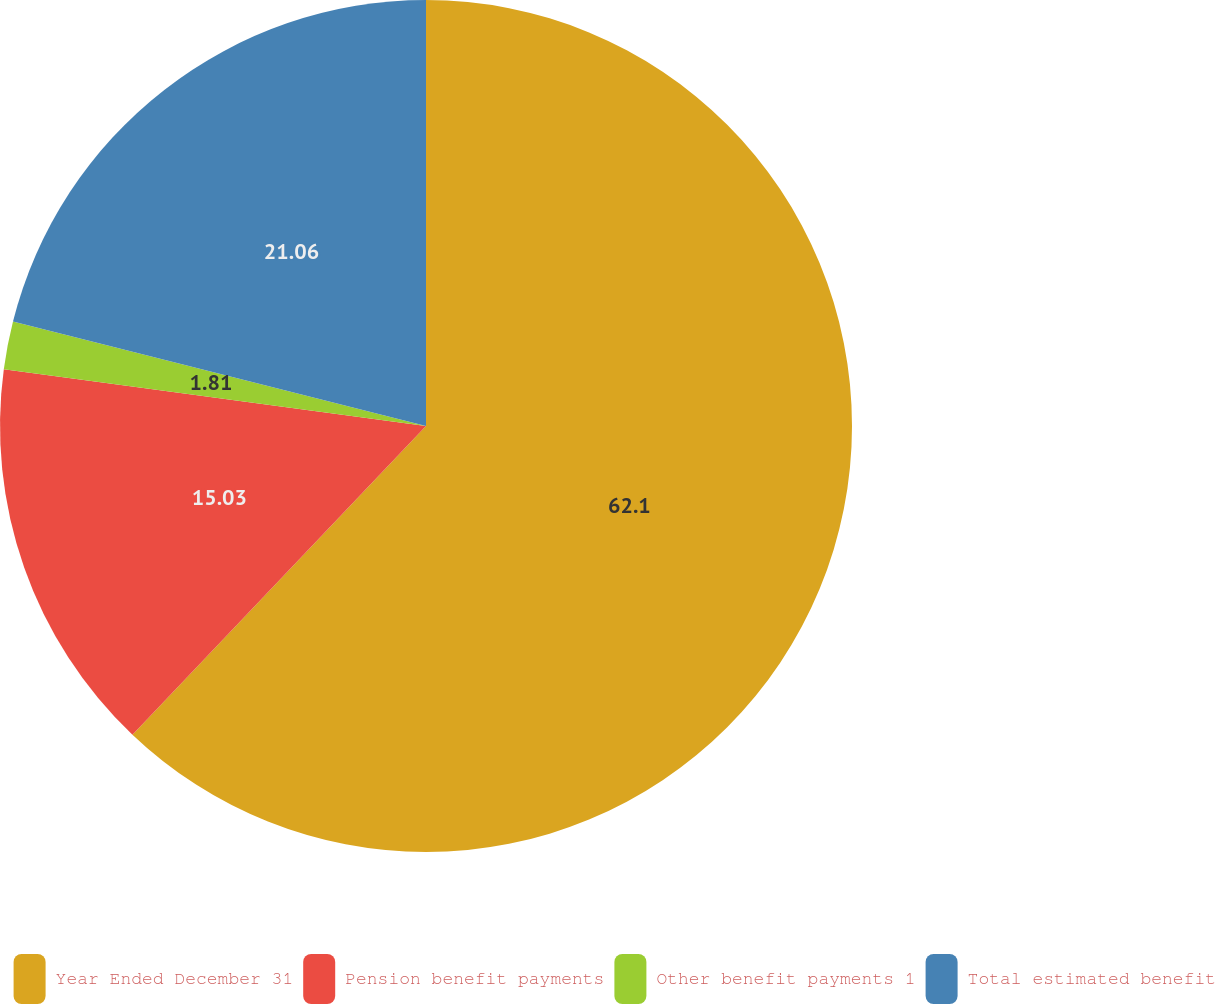Convert chart. <chart><loc_0><loc_0><loc_500><loc_500><pie_chart><fcel>Year Ended December 31<fcel>Pension benefit payments<fcel>Other benefit payments 1<fcel>Total estimated benefit<nl><fcel>62.1%<fcel>15.03%<fcel>1.81%<fcel>21.06%<nl></chart> 